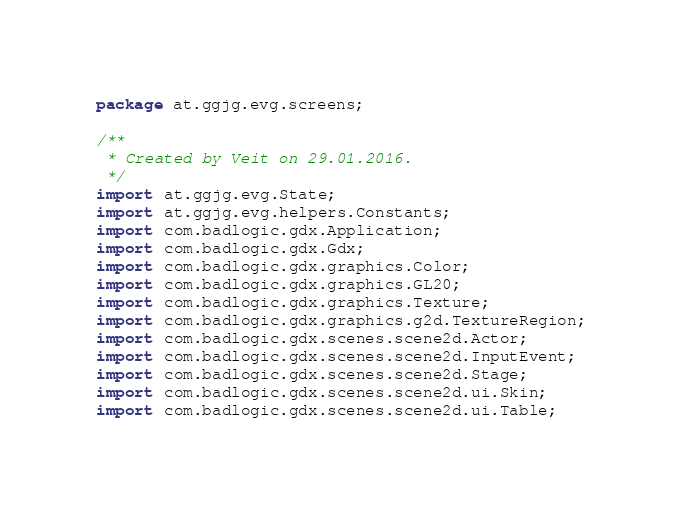<code> <loc_0><loc_0><loc_500><loc_500><_Java_>package at.ggjg.evg.screens;

/**
 * Created by Veit on 29.01.2016.
 */
import at.ggjg.evg.State;
import at.ggjg.evg.helpers.Constants;
import com.badlogic.gdx.Application;
import com.badlogic.gdx.Gdx;
import com.badlogic.gdx.graphics.Color;
import com.badlogic.gdx.graphics.GL20;
import com.badlogic.gdx.graphics.Texture;
import com.badlogic.gdx.graphics.g2d.TextureRegion;
import com.badlogic.gdx.scenes.scene2d.Actor;
import com.badlogic.gdx.scenes.scene2d.InputEvent;
import com.badlogic.gdx.scenes.scene2d.Stage;
import com.badlogic.gdx.scenes.scene2d.ui.Skin;
import com.badlogic.gdx.scenes.scene2d.ui.Table;</code> 